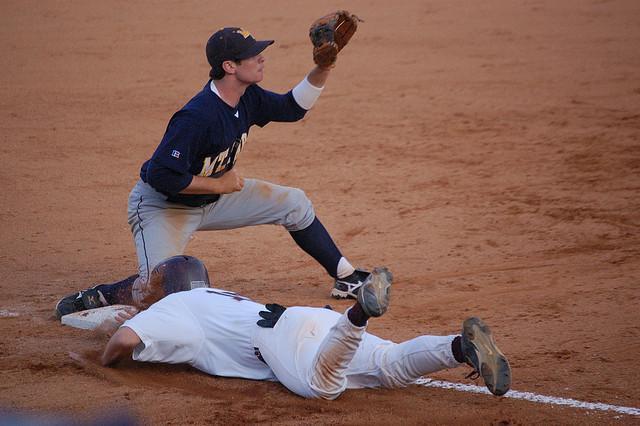How many people can you see?
Give a very brief answer. 2. How many carrots are in the water?
Give a very brief answer. 0. 